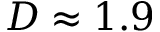<formula> <loc_0><loc_0><loc_500><loc_500>D \approx 1 . 9</formula> 